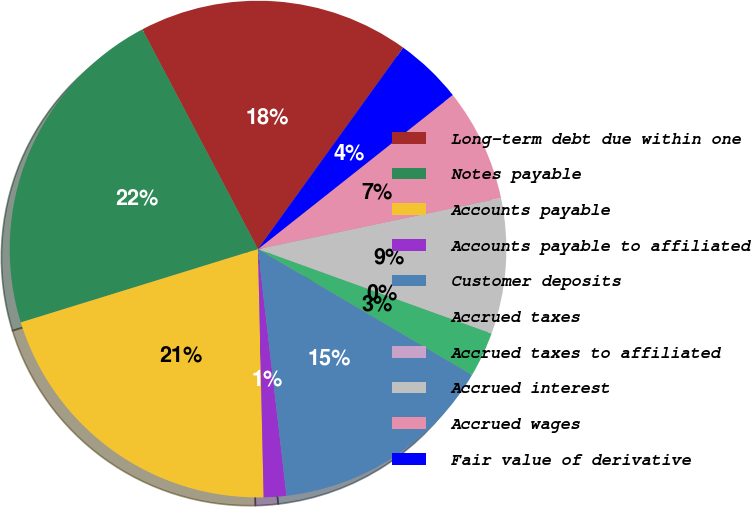Convert chart. <chart><loc_0><loc_0><loc_500><loc_500><pie_chart><fcel>Long-term debt due within one<fcel>Notes payable<fcel>Accounts payable<fcel>Accounts payable to affiliated<fcel>Customer deposits<fcel>Accrued taxes<fcel>Accrued taxes to affiliated<fcel>Accrued interest<fcel>Accrued wages<fcel>Fair value of derivative<nl><fcel>17.65%<fcel>22.06%<fcel>20.59%<fcel>1.47%<fcel>14.71%<fcel>2.94%<fcel>0.0%<fcel>8.82%<fcel>7.35%<fcel>4.41%<nl></chart> 